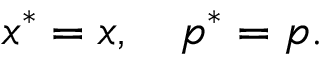Convert formula to latex. <formula><loc_0><loc_0><loc_500><loc_500>x ^ { \ast } = x , \quad p ^ { \ast } = p .</formula> 